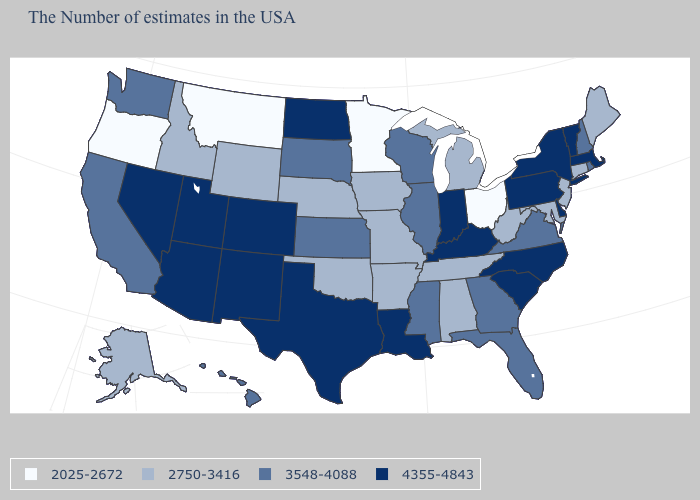What is the value of Connecticut?
Concise answer only. 2750-3416. Among the states that border Colorado , which have the lowest value?
Answer briefly. Nebraska, Oklahoma, Wyoming. Is the legend a continuous bar?
Short answer required. No. Is the legend a continuous bar?
Answer briefly. No. What is the value of Alaska?
Give a very brief answer. 2750-3416. Does New Jersey have the lowest value in the Northeast?
Give a very brief answer. Yes. Which states have the highest value in the USA?
Quick response, please. Massachusetts, Vermont, New York, Delaware, Pennsylvania, North Carolina, South Carolina, Kentucky, Indiana, Louisiana, Texas, North Dakota, Colorado, New Mexico, Utah, Arizona, Nevada. Name the states that have a value in the range 4355-4843?
Give a very brief answer. Massachusetts, Vermont, New York, Delaware, Pennsylvania, North Carolina, South Carolina, Kentucky, Indiana, Louisiana, Texas, North Dakota, Colorado, New Mexico, Utah, Arizona, Nevada. What is the highest value in the USA?
Give a very brief answer. 4355-4843. Does the map have missing data?
Be succinct. No. Among the states that border Tennessee , does North Carolina have the highest value?
Keep it brief. Yes. Does Hawaii have the same value as Indiana?
Keep it brief. No. Does the map have missing data?
Quick response, please. No. What is the lowest value in the USA?
Short answer required. 2025-2672. Among the states that border Mississippi , does Louisiana have the highest value?
Quick response, please. Yes. 